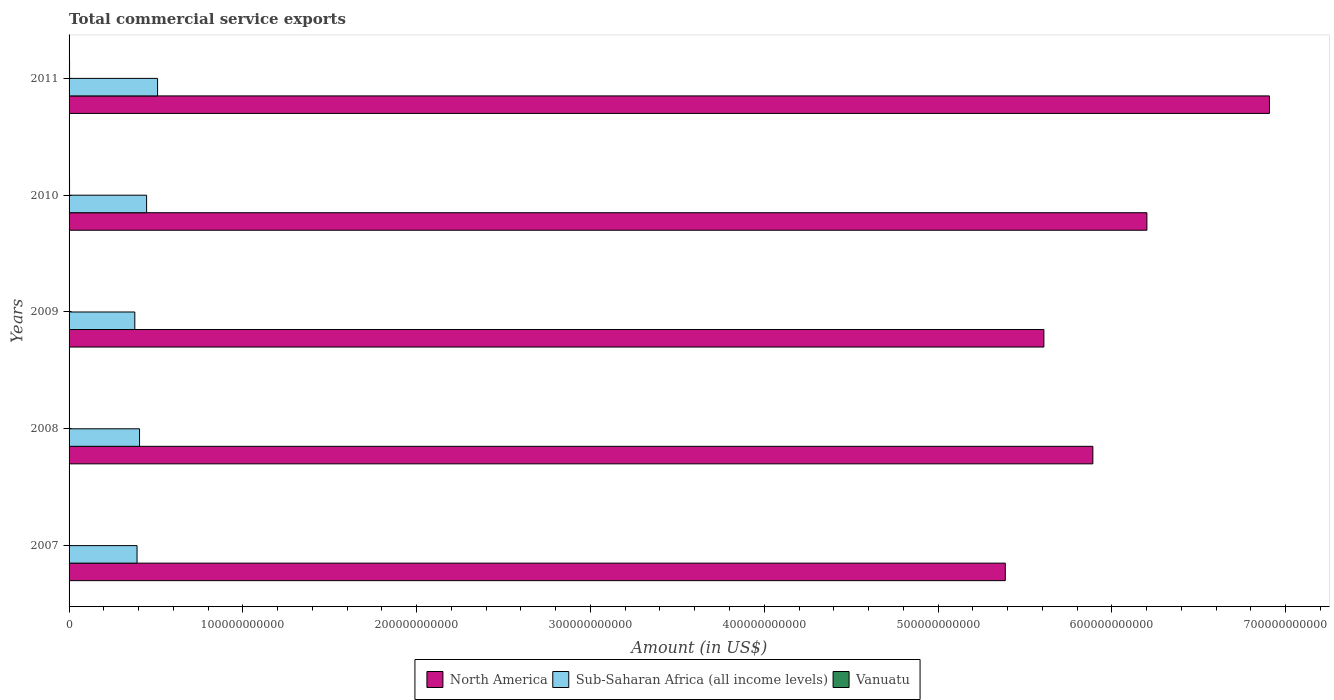How many bars are there on the 2nd tick from the top?
Ensure brevity in your answer.  3. How many bars are there on the 3rd tick from the bottom?
Provide a short and direct response. 3. In how many cases, is the number of bars for a given year not equal to the number of legend labels?
Your answer should be very brief. 0. What is the total commercial service exports in Sub-Saharan Africa (all income levels) in 2008?
Make the answer very short. 4.05e+1. Across all years, what is the maximum total commercial service exports in North America?
Provide a succinct answer. 6.91e+11. Across all years, what is the minimum total commercial service exports in Sub-Saharan Africa (all income levels)?
Ensure brevity in your answer.  3.78e+1. What is the total total commercial service exports in North America in the graph?
Your response must be concise. 3.00e+12. What is the difference between the total commercial service exports in Sub-Saharan Africa (all income levels) in 2007 and that in 2009?
Make the answer very short. 1.29e+09. What is the difference between the total commercial service exports in Sub-Saharan Africa (all income levels) in 2010 and the total commercial service exports in North America in 2009?
Your answer should be compact. -5.16e+11. What is the average total commercial service exports in North America per year?
Your answer should be very brief. 6.00e+11. In the year 2011, what is the difference between the total commercial service exports in Vanuatu and total commercial service exports in Sub-Saharan Africa (all income levels)?
Your answer should be very brief. -5.06e+1. In how many years, is the total commercial service exports in Vanuatu greater than 320000000000 US$?
Offer a very short reply. 0. What is the ratio of the total commercial service exports in North America in 2008 to that in 2010?
Provide a short and direct response. 0.95. What is the difference between the highest and the second highest total commercial service exports in Sub-Saharan Africa (all income levels)?
Your answer should be very brief. 6.31e+09. What is the difference between the highest and the lowest total commercial service exports in Sub-Saharan Africa (all income levels)?
Keep it short and to the point. 1.31e+1. What does the 3rd bar from the top in 2007 represents?
Ensure brevity in your answer.  North America. What does the 3rd bar from the bottom in 2010 represents?
Provide a short and direct response. Vanuatu. Is it the case that in every year, the sum of the total commercial service exports in North America and total commercial service exports in Sub-Saharan Africa (all income levels) is greater than the total commercial service exports in Vanuatu?
Your answer should be very brief. Yes. How many bars are there?
Your answer should be compact. 15. Are all the bars in the graph horizontal?
Offer a terse response. Yes. What is the difference between two consecutive major ticks on the X-axis?
Your response must be concise. 1.00e+11. Are the values on the major ticks of X-axis written in scientific E-notation?
Offer a terse response. No. Does the graph contain any zero values?
Offer a very short reply. No. Does the graph contain grids?
Make the answer very short. No. What is the title of the graph?
Offer a terse response. Total commercial service exports. What is the label or title of the Y-axis?
Your response must be concise. Years. What is the Amount (in US$) of North America in 2007?
Your answer should be very brief. 5.39e+11. What is the Amount (in US$) of Sub-Saharan Africa (all income levels) in 2007?
Offer a very short reply. 3.91e+1. What is the Amount (in US$) of Vanuatu in 2007?
Offer a terse response. 1.77e+08. What is the Amount (in US$) in North America in 2008?
Offer a very short reply. 5.89e+11. What is the Amount (in US$) in Sub-Saharan Africa (all income levels) in 2008?
Keep it short and to the point. 4.05e+1. What is the Amount (in US$) in Vanuatu in 2008?
Offer a very short reply. 2.25e+08. What is the Amount (in US$) in North America in 2009?
Provide a short and direct response. 5.61e+11. What is the Amount (in US$) in Sub-Saharan Africa (all income levels) in 2009?
Ensure brevity in your answer.  3.78e+1. What is the Amount (in US$) of Vanuatu in 2009?
Make the answer very short. 2.41e+08. What is the Amount (in US$) in North America in 2010?
Your response must be concise. 6.20e+11. What is the Amount (in US$) of Sub-Saharan Africa (all income levels) in 2010?
Offer a terse response. 4.46e+1. What is the Amount (in US$) in Vanuatu in 2010?
Ensure brevity in your answer.  2.71e+08. What is the Amount (in US$) in North America in 2011?
Your answer should be very brief. 6.91e+11. What is the Amount (in US$) in Sub-Saharan Africa (all income levels) in 2011?
Your answer should be very brief. 5.09e+1. What is the Amount (in US$) in Vanuatu in 2011?
Your response must be concise. 2.81e+08. Across all years, what is the maximum Amount (in US$) in North America?
Make the answer very short. 6.91e+11. Across all years, what is the maximum Amount (in US$) of Sub-Saharan Africa (all income levels)?
Make the answer very short. 5.09e+1. Across all years, what is the maximum Amount (in US$) in Vanuatu?
Provide a short and direct response. 2.81e+08. Across all years, what is the minimum Amount (in US$) in North America?
Provide a short and direct response. 5.39e+11. Across all years, what is the minimum Amount (in US$) in Sub-Saharan Africa (all income levels)?
Provide a short and direct response. 3.78e+1. Across all years, what is the minimum Amount (in US$) in Vanuatu?
Your response must be concise. 1.77e+08. What is the total Amount (in US$) in North America in the graph?
Your response must be concise. 3.00e+12. What is the total Amount (in US$) of Sub-Saharan Africa (all income levels) in the graph?
Provide a short and direct response. 2.13e+11. What is the total Amount (in US$) in Vanuatu in the graph?
Keep it short and to the point. 1.20e+09. What is the difference between the Amount (in US$) in North America in 2007 and that in 2008?
Make the answer very short. -5.04e+1. What is the difference between the Amount (in US$) in Sub-Saharan Africa (all income levels) in 2007 and that in 2008?
Make the answer very short. -1.43e+09. What is the difference between the Amount (in US$) of Vanuatu in 2007 and that in 2008?
Offer a terse response. -4.83e+07. What is the difference between the Amount (in US$) in North America in 2007 and that in 2009?
Keep it short and to the point. -2.22e+1. What is the difference between the Amount (in US$) in Sub-Saharan Africa (all income levels) in 2007 and that in 2009?
Make the answer very short. 1.29e+09. What is the difference between the Amount (in US$) in Vanuatu in 2007 and that in 2009?
Make the answer very short. -6.40e+07. What is the difference between the Amount (in US$) of North America in 2007 and that in 2010?
Make the answer very short. -8.15e+1. What is the difference between the Amount (in US$) in Sub-Saharan Africa (all income levels) in 2007 and that in 2010?
Keep it short and to the point. -5.50e+09. What is the difference between the Amount (in US$) of Vanuatu in 2007 and that in 2010?
Offer a terse response. -9.42e+07. What is the difference between the Amount (in US$) of North America in 2007 and that in 2011?
Provide a succinct answer. -1.52e+11. What is the difference between the Amount (in US$) in Sub-Saharan Africa (all income levels) in 2007 and that in 2011?
Ensure brevity in your answer.  -1.18e+1. What is the difference between the Amount (in US$) in Vanuatu in 2007 and that in 2011?
Provide a short and direct response. -1.04e+08. What is the difference between the Amount (in US$) in North America in 2008 and that in 2009?
Your answer should be very brief. 2.82e+1. What is the difference between the Amount (in US$) in Sub-Saharan Africa (all income levels) in 2008 and that in 2009?
Give a very brief answer. 2.71e+09. What is the difference between the Amount (in US$) of Vanuatu in 2008 and that in 2009?
Your answer should be compact. -1.57e+07. What is the difference between the Amount (in US$) in North America in 2008 and that in 2010?
Your answer should be very brief. -3.11e+1. What is the difference between the Amount (in US$) in Sub-Saharan Africa (all income levels) in 2008 and that in 2010?
Ensure brevity in your answer.  -4.07e+09. What is the difference between the Amount (in US$) of Vanuatu in 2008 and that in 2010?
Offer a very short reply. -4.59e+07. What is the difference between the Amount (in US$) of North America in 2008 and that in 2011?
Your answer should be compact. -1.02e+11. What is the difference between the Amount (in US$) of Sub-Saharan Africa (all income levels) in 2008 and that in 2011?
Give a very brief answer. -1.04e+1. What is the difference between the Amount (in US$) of Vanuatu in 2008 and that in 2011?
Your answer should be very brief. -5.62e+07. What is the difference between the Amount (in US$) of North America in 2009 and that in 2010?
Provide a short and direct response. -5.93e+1. What is the difference between the Amount (in US$) in Sub-Saharan Africa (all income levels) in 2009 and that in 2010?
Your answer should be very brief. -6.79e+09. What is the difference between the Amount (in US$) in Vanuatu in 2009 and that in 2010?
Offer a terse response. -3.02e+07. What is the difference between the Amount (in US$) in North America in 2009 and that in 2011?
Keep it short and to the point. -1.30e+11. What is the difference between the Amount (in US$) in Sub-Saharan Africa (all income levels) in 2009 and that in 2011?
Keep it short and to the point. -1.31e+1. What is the difference between the Amount (in US$) of Vanuatu in 2009 and that in 2011?
Offer a very short reply. -4.05e+07. What is the difference between the Amount (in US$) of North America in 2010 and that in 2011?
Offer a very short reply. -7.05e+1. What is the difference between the Amount (in US$) in Sub-Saharan Africa (all income levels) in 2010 and that in 2011?
Your answer should be compact. -6.31e+09. What is the difference between the Amount (in US$) in Vanuatu in 2010 and that in 2011?
Your answer should be very brief. -1.03e+07. What is the difference between the Amount (in US$) of North America in 2007 and the Amount (in US$) of Sub-Saharan Africa (all income levels) in 2008?
Your answer should be compact. 4.98e+11. What is the difference between the Amount (in US$) in North America in 2007 and the Amount (in US$) in Vanuatu in 2008?
Ensure brevity in your answer.  5.38e+11. What is the difference between the Amount (in US$) in Sub-Saharan Africa (all income levels) in 2007 and the Amount (in US$) in Vanuatu in 2008?
Make the answer very short. 3.89e+1. What is the difference between the Amount (in US$) of North America in 2007 and the Amount (in US$) of Sub-Saharan Africa (all income levels) in 2009?
Your response must be concise. 5.01e+11. What is the difference between the Amount (in US$) in North America in 2007 and the Amount (in US$) in Vanuatu in 2009?
Make the answer very short. 5.38e+11. What is the difference between the Amount (in US$) in Sub-Saharan Africa (all income levels) in 2007 and the Amount (in US$) in Vanuatu in 2009?
Your answer should be very brief. 3.89e+1. What is the difference between the Amount (in US$) in North America in 2007 and the Amount (in US$) in Sub-Saharan Africa (all income levels) in 2010?
Your answer should be very brief. 4.94e+11. What is the difference between the Amount (in US$) of North America in 2007 and the Amount (in US$) of Vanuatu in 2010?
Your answer should be compact. 5.38e+11. What is the difference between the Amount (in US$) of Sub-Saharan Africa (all income levels) in 2007 and the Amount (in US$) of Vanuatu in 2010?
Your answer should be very brief. 3.88e+1. What is the difference between the Amount (in US$) of North America in 2007 and the Amount (in US$) of Sub-Saharan Africa (all income levels) in 2011?
Provide a succinct answer. 4.88e+11. What is the difference between the Amount (in US$) of North America in 2007 and the Amount (in US$) of Vanuatu in 2011?
Ensure brevity in your answer.  5.38e+11. What is the difference between the Amount (in US$) in Sub-Saharan Africa (all income levels) in 2007 and the Amount (in US$) in Vanuatu in 2011?
Make the answer very short. 3.88e+1. What is the difference between the Amount (in US$) in North America in 2008 and the Amount (in US$) in Sub-Saharan Africa (all income levels) in 2009?
Offer a very short reply. 5.51e+11. What is the difference between the Amount (in US$) of North America in 2008 and the Amount (in US$) of Vanuatu in 2009?
Offer a very short reply. 5.89e+11. What is the difference between the Amount (in US$) in Sub-Saharan Africa (all income levels) in 2008 and the Amount (in US$) in Vanuatu in 2009?
Your answer should be compact. 4.03e+1. What is the difference between the Amount (in US$) in North America in 2008 and the Amount (in US$) in Sub-Saharan Africa (all income levels) in 2010?
Your answer should be compact. 5.44e+11. What is the difference between the Amount (in US$) of North America in 2008 and the Amount (in US$) of Vanuatu in 2010?
Your answer should be very brief. 5.89e+11. What is the difference between the Amount (in US$) of Sub-Saharan Africa (all income levels) in 2008 and the Amount (in US$) of Vanuatu in 2010?
Provide a short and direct response. 4.03e+1. What is the difference between the Amount (in US$) of North America in 2008 and the Amount (in US$) of Sub-Saharan Africa (all income levels) in 2011?
Offer a terse response. 5.38e+11. What is the difference between the Amount (in US$) of North America in 2008 and the Amount (in US$) of Vanuatu in 2011?
Your answer should be compact. 5.89e+11. What is the difference between the Amount (in US$) of Sub-Saharan Africa (all income levels) in 2008 and the Amount (in US$) of Vanuatu in 2011?
Your response must be concise. 4.03e+1. What is the difference between the Amount (in US$) in North America in 2009 and the Amount (in US$) in Sub-Saharan Africa (all income levels) in 2010?
Ensure brevity in your answer.  5.16e+11. What is the difference between the Amount (in US$) of North America in 2009 and the Amount (in US$) of Vanuatu in 2010?
Your answer should be compact. 5.61e+11. What is the difference between the Amount (in US$) in Sub-Saharan Africa (all income levels) in 2009 and the Amount (in US$) in Vanuatu in 2010?
Offer a terse response. 3.76e+1. What is the difference between the Amount (in US$) in North America in 2009 and the Amount (in US$) in Sub-Saharan Africa (all income levels) in 2011?
Offer a very short reply. 5.10e+11. What is the difference between the Amount (in US$) in North America in 2009 and the Amount (in US$) in Vanuatu in 2011?
Give a very brief answer. 5.61e+11. What is the difference between the Amount (in US$) of Sub-Saharan Africa (all income levels) in 2009 and the Amount (in US$) of Vanuatu in 2011?
Keep it short and to the point. 3.75e+1. What is the difference between the Amount (in US$) of North America in 2010 and the Amount (in US$) of Sub-Saharan Africa (all income levels) in 2011?
Ensure brevity in your answer.  5.69e+11. What is the difference between the Amount (in US$) of North America in 2010 and the Amount (in US$) of Vanuatu in 2011?
Your response must be concise. 6.20e+11. What is the difference between the Amount (in US$) in Sub-Saharan Africa (all income levels) in 2010 and the Amount (in US$) in Vanuatu in 2011?
Offer a very short reply. 4.43e+1. What is the average Amount (in US$) in North America per year?
Ensure brevity in your answer.  6.00e+11. What is the average Amount (in US$) of Sub-Saharan Africa (all income levels) per year?
Make the answer very short. 4.26e+1. What is the average Amount (in US$) of Vanuatu per year?
Give a very brief answer. 2.39e+08. In the year 2007, what is the difference between the Amount (in US$) in North America and Amount (in US$) in Sub-Saharan Africa (all income levels)?
Your answer should be very brief. 5.00e+11. In the year 2007, what is the difference between the Amount (in US$) of North America and Amount (in US$) of Vanuatu?
Ensure brevity in your answer.  5.39e+11. In the year 2007, what is the difference between the Amount (in US$) in Sub-Saharan Africa (all income levels) and Amount (in US$) in Vanuatu?
Keep it short and to the point. 3.89e+1. In the year 2008, what is the difference between the Amount (in US$) of North America and Amount (in US$) of Sub-Saharan Africa (all income levels)?
Give a very brief answer. 5.49e+11. In the year 2008, what is the difference between the Amount (in US$) in North America and Amount (in US$) in Vanuatu?
Offer a terse response. 5.89e+11. In the year 2008, what is the difference between the Amount (in US$) in Sub-Saharan Africa (all income levels) and Amount (in US$) in Vanuatu?
Ensure brevity in your answer.  4.03e+1. In the year 2009, what is the difference between the Amount (in US$) in North America and Amount (in US$) in Sub-Saharan Africa (all income levels)?
Offer a terse response. 5.23e+11. In the year 2009, what is the difference between the Amount (in US$) of North America and Amount (in US$) of Vanuatu?
Provide a short and direct response. 5.61e+11. In the year 2009, what is the difference between the Amount (in US$) of Sub-Saharan Africa (all income levels) and Amount (in US$) of Vanuatu?
Make the answer very short. 3.76e+1. In the year 2010, what is the difference between the Amount (in US$) in North America and Amount (in US$) in Sub-Saharan Africa (all income levels)?
Keep it short and to the point. 5.76e+11. In the year 2010, what is the difference between the Amount (in US$) in North America and Amount (in US$) in Vanuatu?
Provide a succinct answer. 6.20e+11. In the year 2010, what is the difference between the Amount (in US$) of Sub-Saharan Africa (all income levels) and Amount (in US$) of Vanuatu?
Your response must be concise. 4.43e+1. In the year 2011, what is the difference between the Amount (in US$) of North America and Amount (in US$) of Sub-Saharan Africa (all income levels)?
Offer a very short reply. 6.40e+11. In the year 2011, what is the difference between the Amount (in US$) in North America and Amount (in US$) in Vanuatu?
Keep it short and to the point. 6.90e+11. In the year 2011, what is the difference between the Amount (in US$) of Sub-Saharan Africa (all income levels) and Amount (in US$) of Vanuatu?
Make the answer very short. 5.06e+1. What is the ratio of the Amount (in US$) in North America in 2007 to that in 2008?
Ensure brevity in your answer.  0.91. What is the ratio of the Amount (in US$) in Sub-Saharan Africa (all income levels) in 2007 to that in 2008?
Offer a terse response. 0.96. What is the ratio of the Amount (in US$) in Vanuatu in 2007 to that in 2008?
Provide a succinct answer. 0.79. What is the ratio of the Amount (in US$) in North America in 2007 to that in 2009?
Keep it short and to the point. 0.96. What is the ratio of the Amount (in US$) in Sub-Saharan Africa (all income levels) in 2007 to that in 2009?
Make the answer very short. 1.03. What is the ratio of the Amount (in US$) of Vanuatu in 2007 to that in 2009?
Give a very brief answer. 0.73. What is the ratio of the Amount (in US$) of North America in 2007 to that in 2010?
Keep it short and to the point. 0.87. What is the ratio of the Amount (in US$) in Sub-Saharan Africa (all income levels) in 2007 to that in 2010?
Provide a succinct answer. 0.88. What is the ratio of the Amount (in US$) in Vanuatu in 2007 to that in 2010?
Give a very brief answer. 0.65. What is the ratio of the Amount (in US$) of North America in 2007 to that in 2011?
Provide a succinct answer. 0.78. What is the ratio of the Amount (in US$) in Sub-Saharan Africa (all income levels) in 2007 to that in 2011?
Give a very brief answer. 0.77. What is the ratio of the Amount (in US$) of Vanuatu in 2007 to that in 2011?
Your answer should be very brief. 0.63. What is the ratio of the Amount (in US$) of North America in 2008 to that in 2009?
Your answer should be very brief. 1.05. What is the ratio of the Amount (in US$) of Sub-Saharan Africa (all income levels) in 2008 to that in 2009?
Give a very brief answer. 1.07. What is the ratio of the Amount (in US$) in Vanuatu in 2008 to that in 2009?
Give a very brief answer. 0.93. What is the ratio of the Amount (in US$) of North America in 2008 to that in 2010?
Provide a short and direct response. 0.95. What is the ratio of the Amount (in US$) in Sub-Saharan Africa (all income levels) in 2008 to that in 2010?
Offer a terse response. 0.91. What is the ratio of the Amount (in US$) of Vanuatu in 2008 to that in 2010?
Your response must be concise. 0.83. What is the ratio of the Amount (in US$) of North America in 2008 to that in 2011?
Ensure brevity in your answer.  0.85. What is the ratio of the Amount (in US$) of Sub-Saharan Africa (all income levels) in 2008 to that in 2011?
Provide a short and direct response. 0.8. What is the ratio of the Amount (in US$) in Vanuatu in 2008 to that in 2011?
Offer a very short reply. 0.8. What is the ratio of the Amount (in US$) in North America in 2009 to that in 2010?
Your answer should be very brief. 0.9. What is the ratio of the Amount (in US$) in Sub-Saharan Africa (all income levels) in 2009 to that in 2010?
Give a very brief answer. 0.85. What is the ratio of the Amount (in US$) in Vanuatu in 2009 to that in 2010?
Provide a succinct answer. 0.89. What is the ratio of the Amount (in US$) of North America in 2009 to that in 2011?
Keep it short and to the point. 0.81. What is the ratio of the Amount (in US$) of Sub-Saharan Africa (all income levels) in 2009 to that in 2011?
Your answer should be compact. 0.74. What is the ratio of the Amount (in US$) of Vanuatu in 2009 to that in 2011?
Offer a terse response. 0.86. What is the ratio of the Amount (in US$) in North America in 2010 to that in 2011?
Your answer should be very brief. 0.9. What is the ratio of the Amount (in US$) of Sub-Saharan Africa (all income levels) in 2010 to that in 2011?
Keep it short and to the point. 0.88. What is the ratio of the Amount (in US$) in Vanuatu in 2010 to that in 2011?
Give a very brief answer. 0.96. What is the difference between the highest and the second highest Amount (in US$) in North America?
Offer a very short reply. 7.05e+1. What is the difference between the highest and the second highest Amount (in US$) of Sub-Saharan Africa (all income levels)?
Ensure brevity in your answer.  6.31e+09. What is the difference between the highest and the second highest Amount (in US$) in Vanuatu?
Offer a very short reply. 1.03e+07. What is the difference between the highest and the lowest Amount (in US$) in North America?
Your answer should be compact. 1.52e+11. What is the difference between the highest and the lowest Amount (in US$) in Sub-Saharan Africa (all income levels)?
Make the answer very short. 1.31e+1. What is the difference between the highest and the lowest Amount (in US$) of Vanuatu?
Offer a terse response. 1.04e+08. 